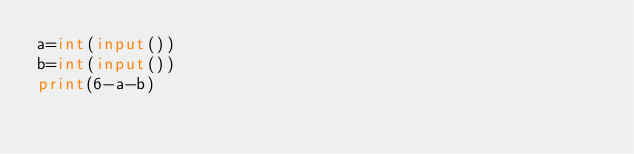Convert code to text. <code><loc_0><loc_0><loc_500><loc_500><_Python_>a=int(input())
b=int(input())
print(6-a-b)
</code> 